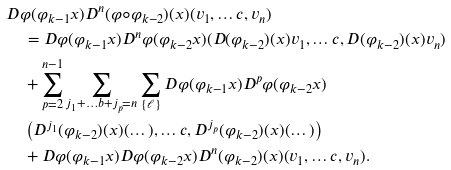Convert formula to latex. <formula><loc_0><loc_0><loc_500><loc_500>& D \varphi ( \varphi _ { k - 1 } x ) D ^ { n } ( \varphi \circ \varphi _ { k - 2 } ) ( x ) ( v _ { 1 } , \dots c , v _ { n } ) \\ & \quad = D \varphi ( \varphi _ { k - 1 } x ) D ^ { n } \varphi ( \varphi _ { k - 2 } x ) ( D ( \varphi _ { k - 2 } ) ( x ) v _ { 1 } , \dots c , D ( \varphi _ { k - 2 } ) ( x ) v _ { n } ) \\ & \quad + \sum ^ { n - 1 } _ { p = 2 } \sum _ { j _ { 1 } + \dots b + j _ { p } = n } \sum _ { \{ \ell \} } D \varphi ( \varphi _ { k - 1 } x ) D ^ { p } \varphi ( \varphi _ { k - 2 } x ) \\ & \quad \left ( D ^ { j _ { 1 } } ( \varphi _ { k - 2 } ) ( x ) ( \dots ) , \dots c , D ^ { j _ { p } } ( \varphi _ { k - 2 } ) ( x ) ( \dots ) \right ) \\ & \quad + D \varphi ( \varphi _ { k - 1 } x ) D \varphi ( \varphi _ { k - 2 } x ) D ^ { n } ( \varphi _ { k - 2 } ) ( x ) ( v _ { 1 } , \dots c , v _ { n } ) .</formula> 